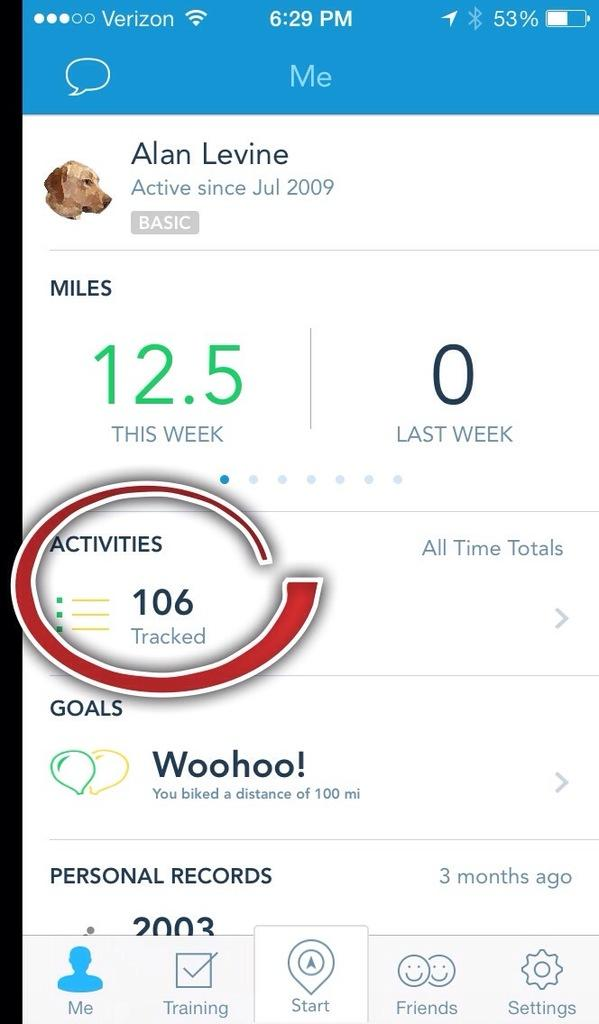<image>
Relay a brief, clear account of the picture shown. Alan Levine has been active in this app since July of 2009. 